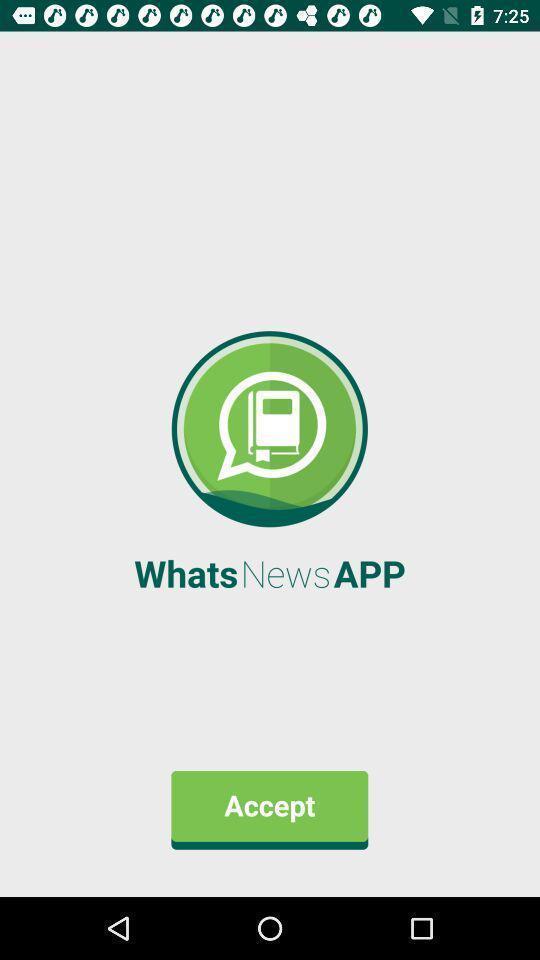Tell me what you see in this picture. Screen asking to accept terms of a news application. 